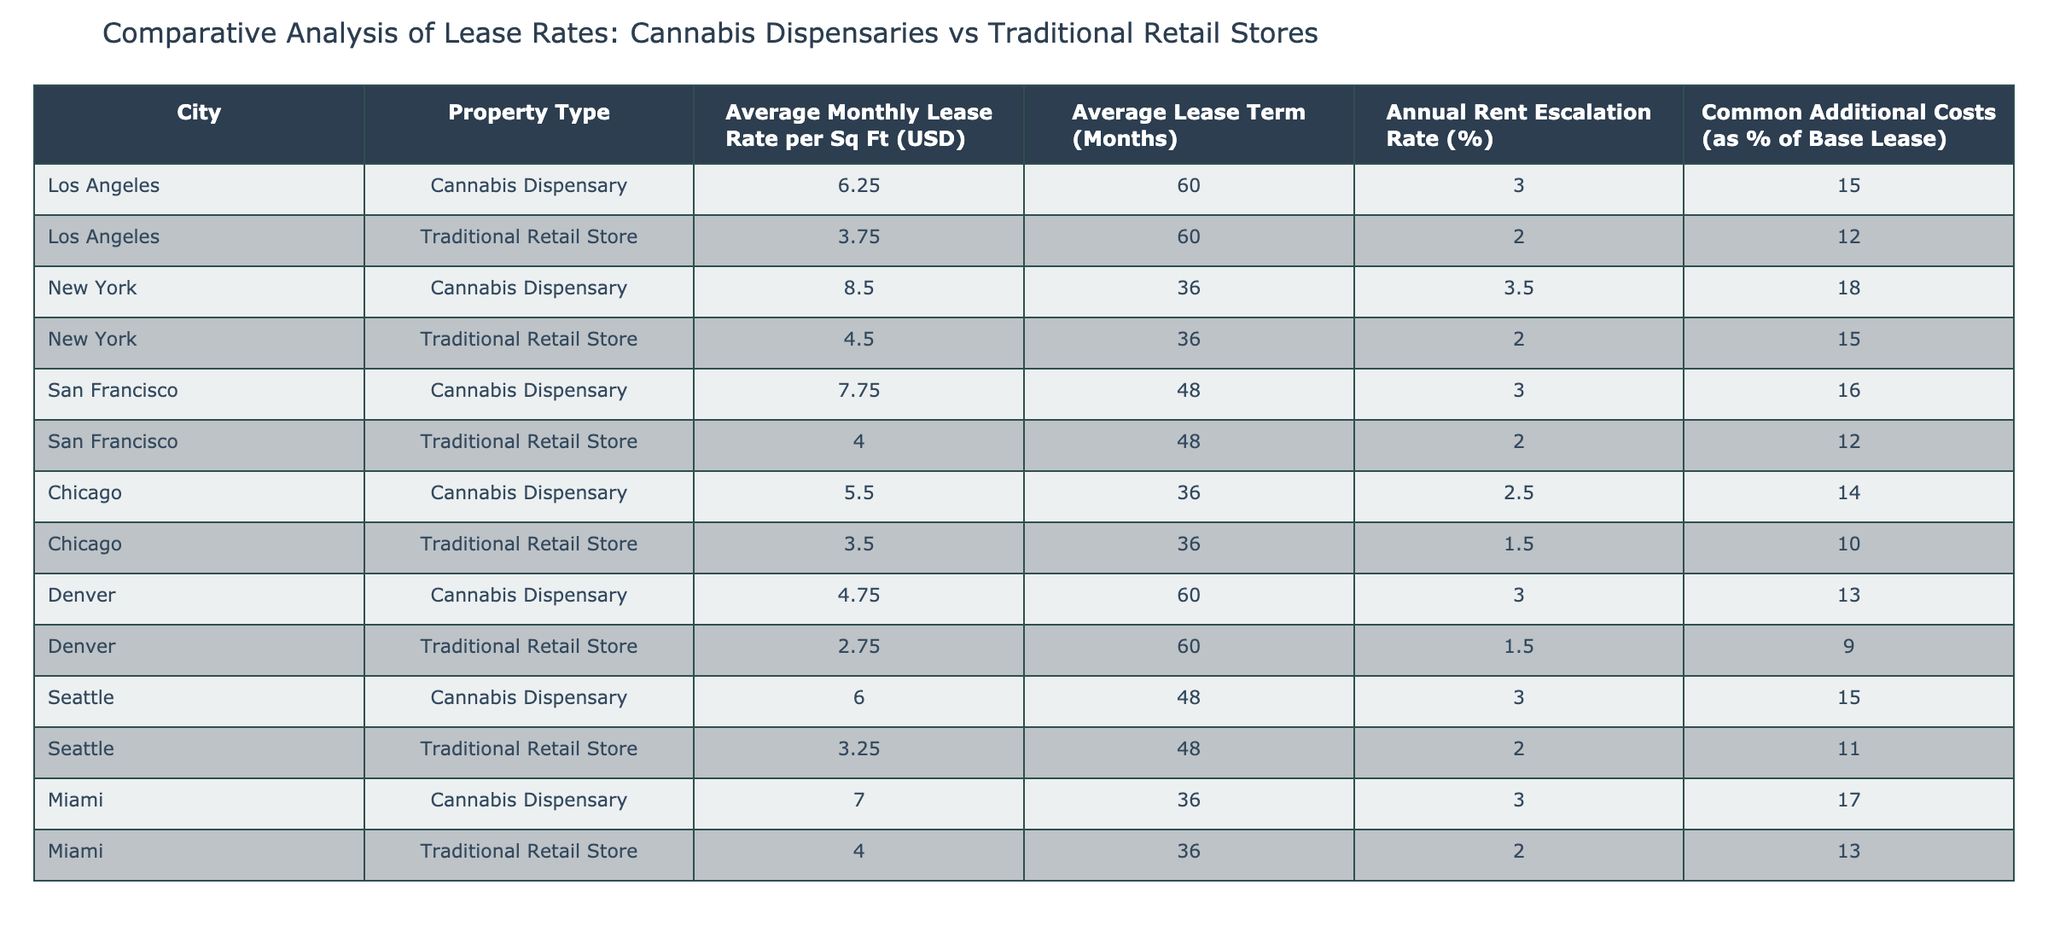What is the average monthly lease rate for cannabis dispensaries in San Francisco? The average monthly lease rate for cannabis dispensaries in San Francisco is provided directly in the table, which lists it as 7.75 USD/sq ft.
Answer: 7.75 Which city has the highest average lease rate for traditional retail stores? The table shows that New York has the highest average lease rate for traditional retail stores at 4.50 USD/sq ft, compared to other cities listed.
Answer: New York What is the difference in average monthly lease rates between cannabis dispensaries and traditional retail stores in Los Angeles? From the table, the average monthly lease rate for cannabis dispensaries in Los Angeles is 6.25 USD/sq ft, and for traditional retail stores, it is 3.75 USD/sq ft. The difference is 6.25 - 3.75 = 2.50 USD/sq ft.
Answer: 2.50 Are the annual rent escalation rates for cannabis dispensaries higher than for traditional retail stores in Chicago? The table lists the annual rent escalation rate for cannabis dispensaries in Chicago as 2.5% and for traditional retail stores as 1.5%. Therefore, cannabis dispensary rates are indeed higher.
Answer: Yes What is the total average monthly lease rate for both cannabis dispensaries and traditional retail stores in Miami? From the table, the average monthly lease rate for cannabis dispensaries in Miami is 7.00 USD/sq ft, and for traditional retail stores, it is 4.00 USD/sq ft. Adding these together gives 7.00 + 4.00 = 11.00 USD/sq ft.
Answer: 11.00 Which property type has a higher common additional cost percentage in New York? The table states that the common additional costs for cannabis dispensaries in New York is 18%, and for traditional retail stores, it is 15%. Since 18% is higher, cannabis dispensaries have greater costs.
Answer: Cannabis Dispensary What is the average lease term for traditional retail stores across all listed cities? Examining the table, the average lease term for traditional retail stores is 60 months for Los Angeles, 36 months for New York, 48 months for San Francisco, 36 months for Chicago, 60 months for Denver, and 48 months for Seattle. Calculating the average: (60 + 36 + 48 + 36 + 60 + 48) / 6 = 48 months.
Answer: 48 In which city do cannabis dispensaries have the lowest lease rate? The table shows that Denver has the lowest average monthly lease rate for cannabis dispensaries at 4.75 USD/sq ft compared to other cities.
Answer: Denver What is the average rent escalation rate for cannabis dispensaries across all the cities listed? The average annual rent escalation rate for cannabis dispensaries can be calculated by summing the rates: (3% + 3.5% + 3% + 2.5% + 3% + 3%) / 6 = 2.92%, which is approximately 2.92%.
Answer: 3.00 (rounded to two decimal places) 